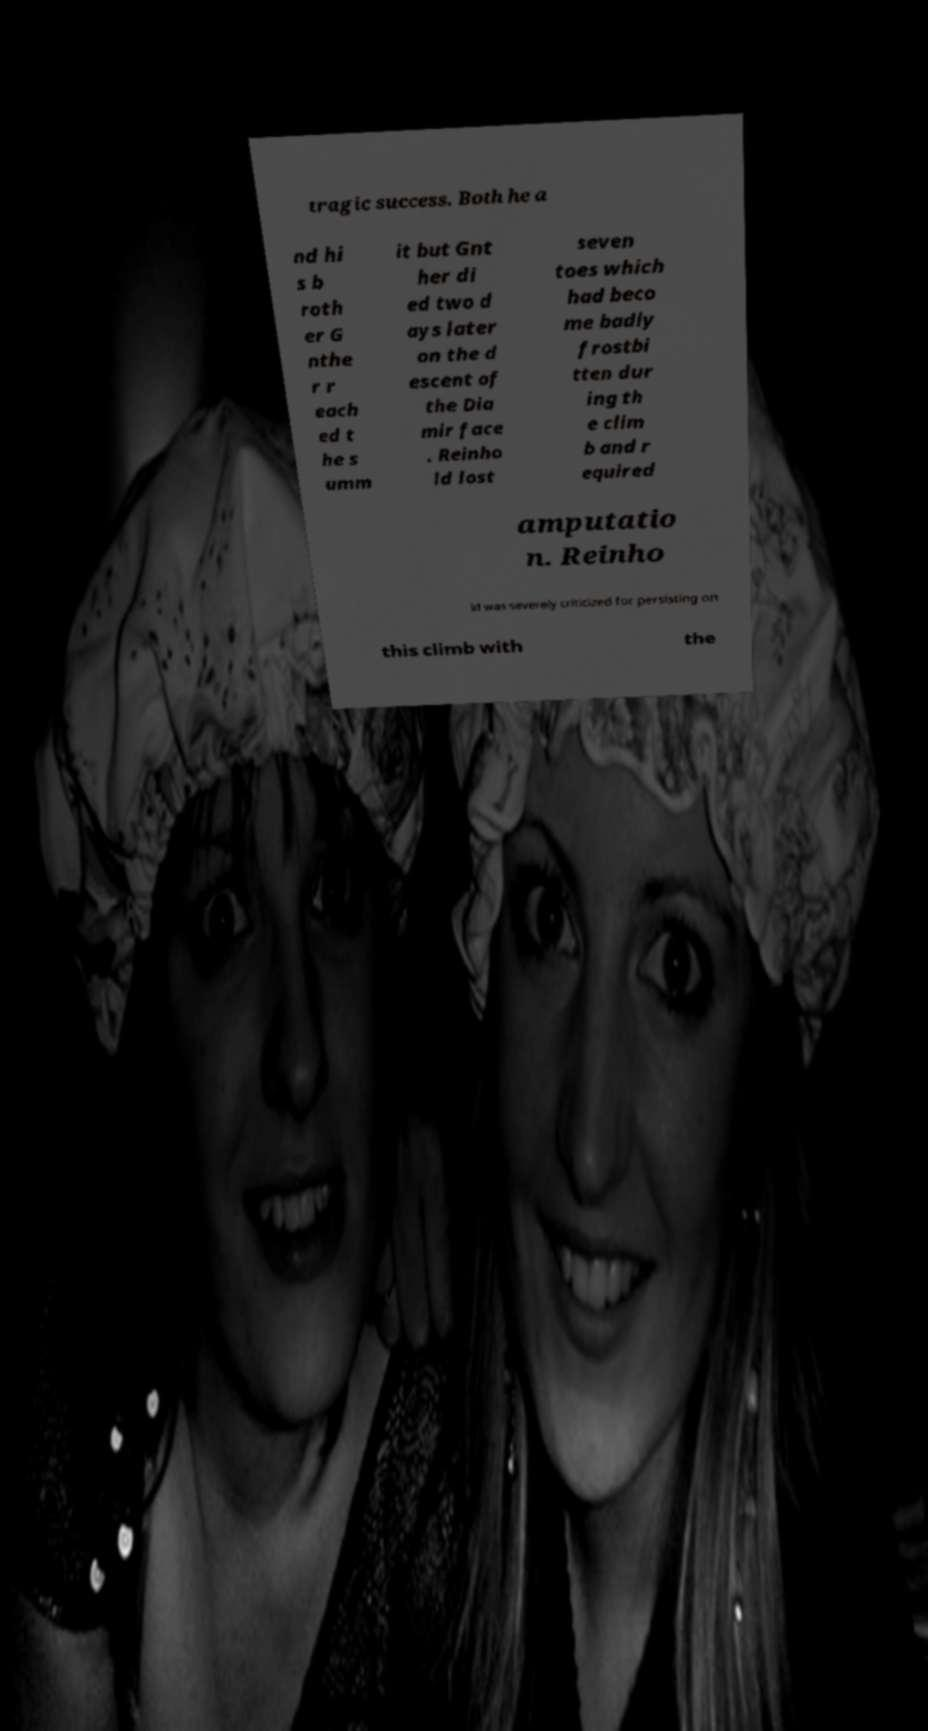Can you accurately transcribe the text from the provided image for me? tragic success. Both he a nd hi s b roth er G nthe r r each ed t he s umm it but Gnt her di ed two d ays later on the d escent of the Dia mir face . Reinho ld lost seven toes which had beco me badly frostbi tten dur ing th e clim b and r equired amputatio n. Reinho ld was severely criticized for persisting on this climb with the 